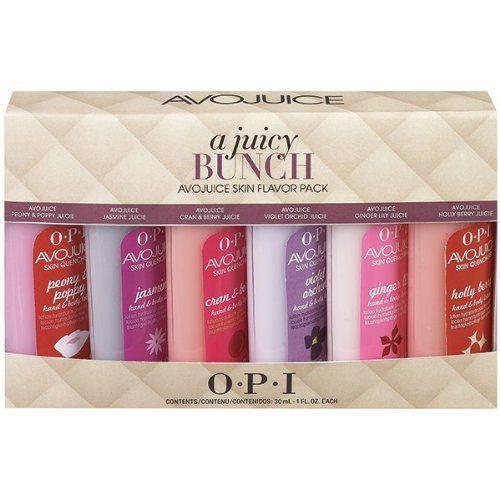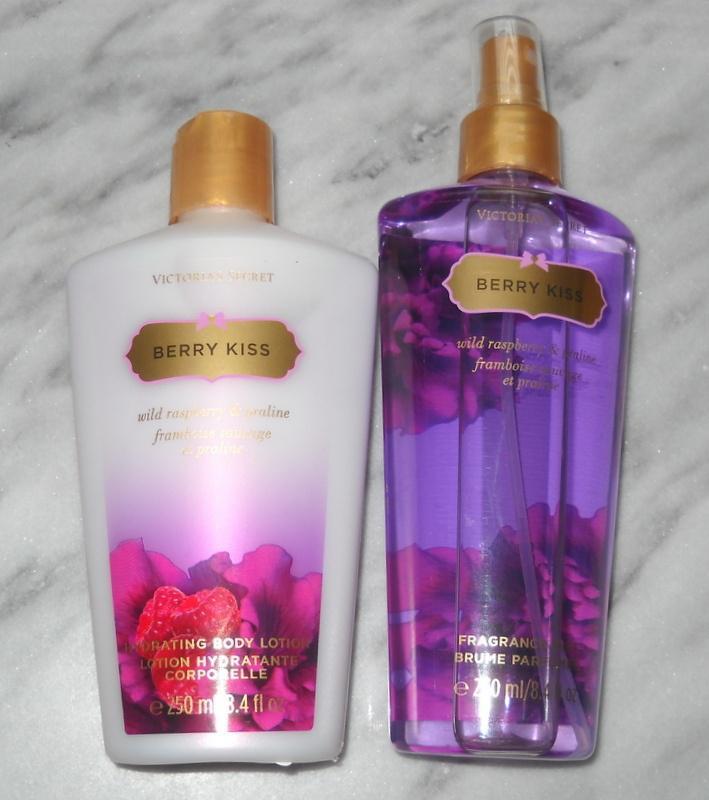The first image is the image on the left, the second image is the image on the right. Given the left and right images, does the statement "Each image shows the same number of skincare products." hold true? Answer yes or no. No. The first image is the image on the left, the second image is the image on the right. For the images displayed, is the sentence "The products on the left are Pink brand." factually correct? Answer yes or no. No. 